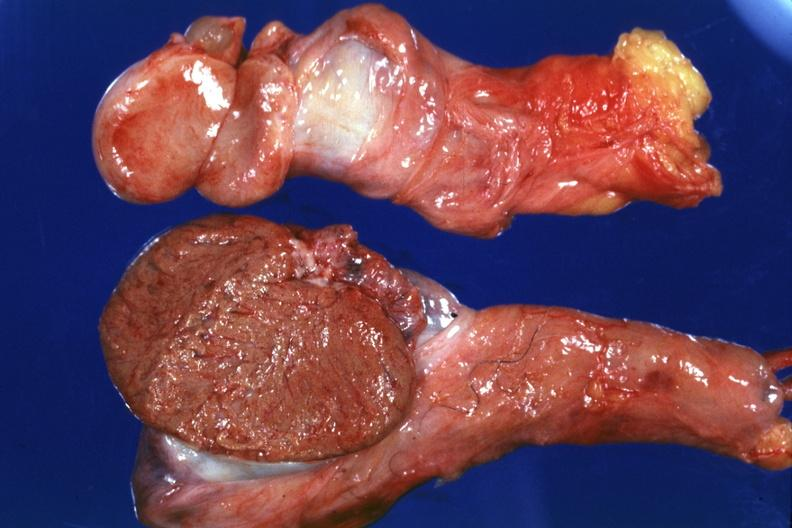why does this image show that cut surface both testicles on normal and one quite small typical probably?
Answer the question using a single word or phrase. Due to mumps have no history at time 